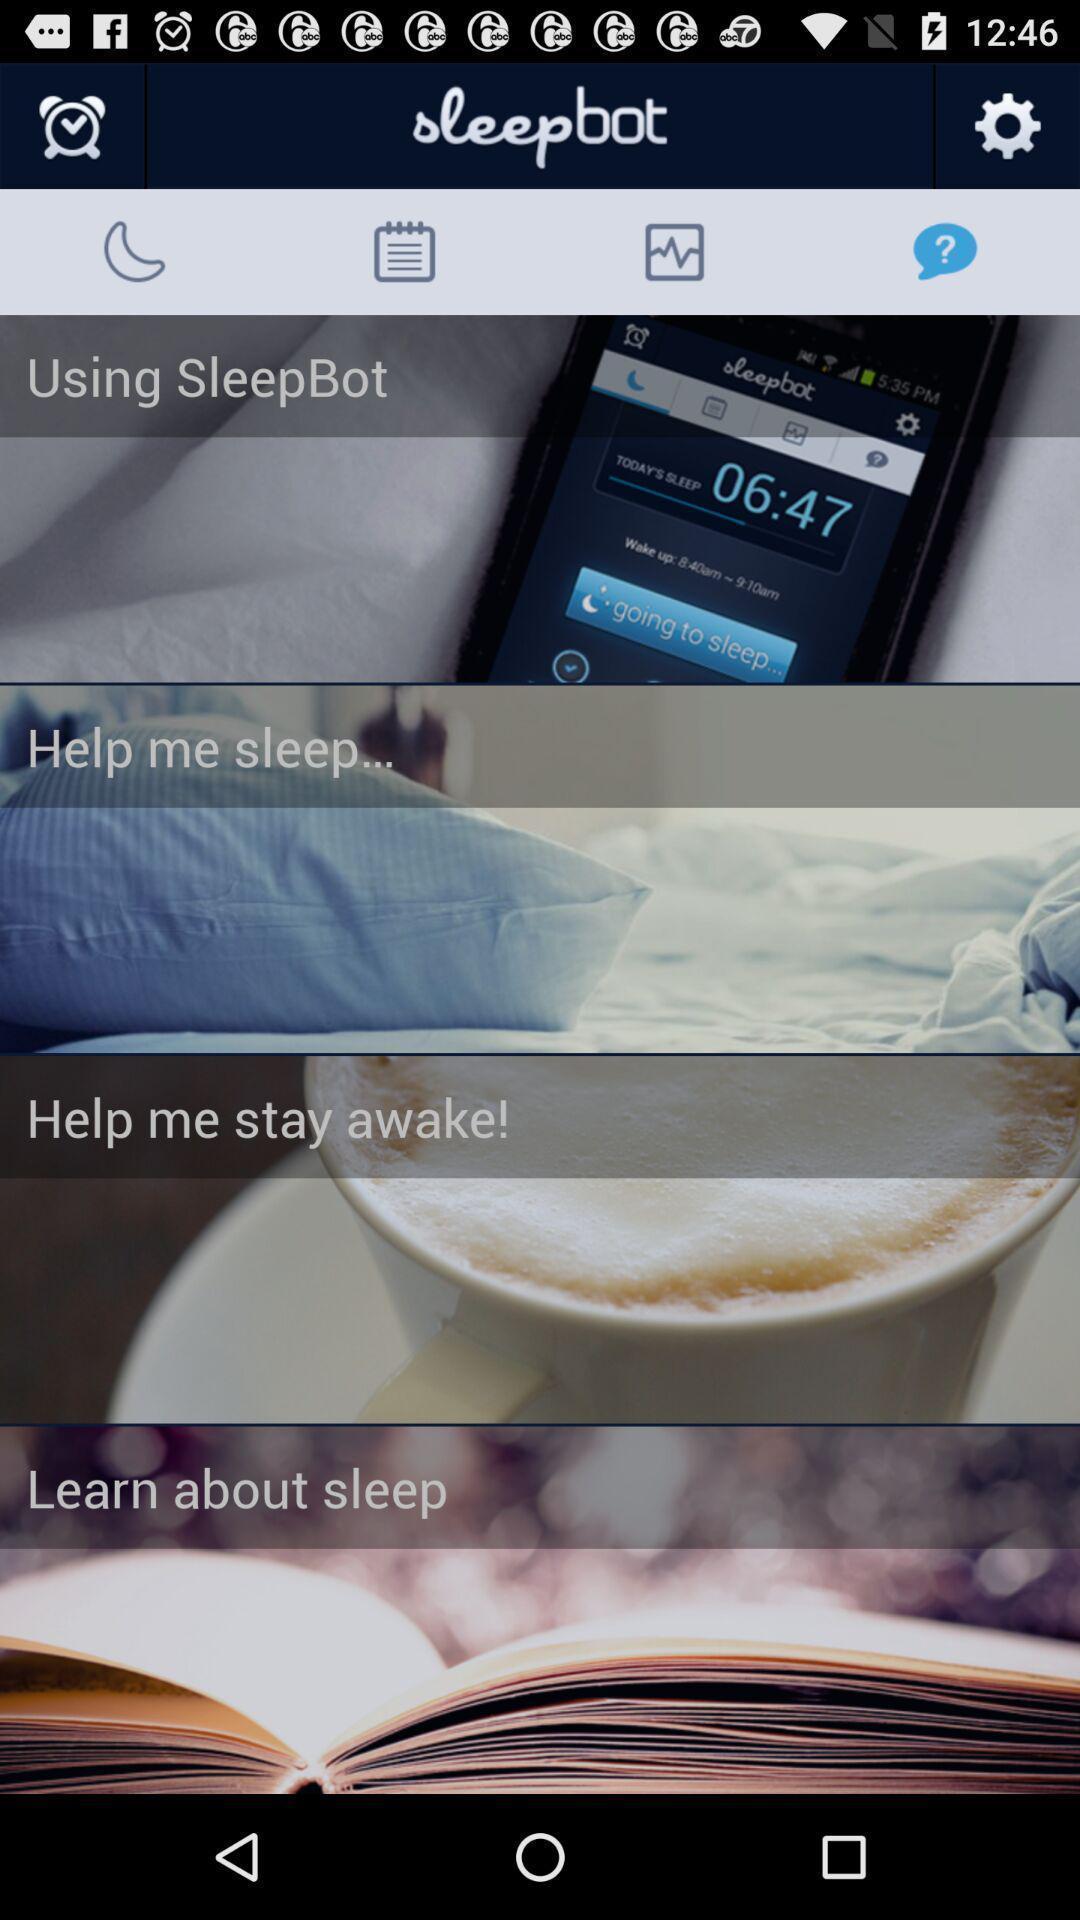Provide a detailed account of this screenshot. Page that displaying app description. 